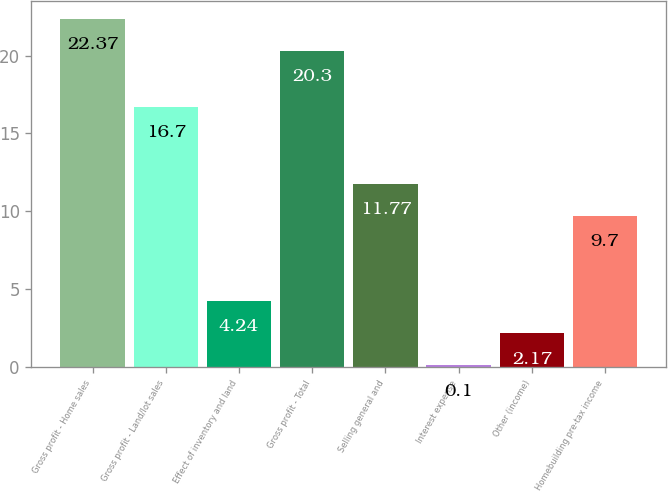Convert chart. <chart><loc_0><loc_0><loc_500><loc_500><bar_chart><fcel>Gross profit - Home sales<fcel>Gross profit - Land/lot sales<fcel>Effect of inventory and land<fcel>Gross profit - Total<fcel>Selling general and<fcel>Interest expense<fcel>Other (income)<fcel>Homebuilding pre-tax income<nl><fcel>22.37<fcel>16.7<fcel>4.24<fcel>20.3<fcel>11.77<fcel>0.1<fcel>2.17<fcel>9.7<nl></chart> 